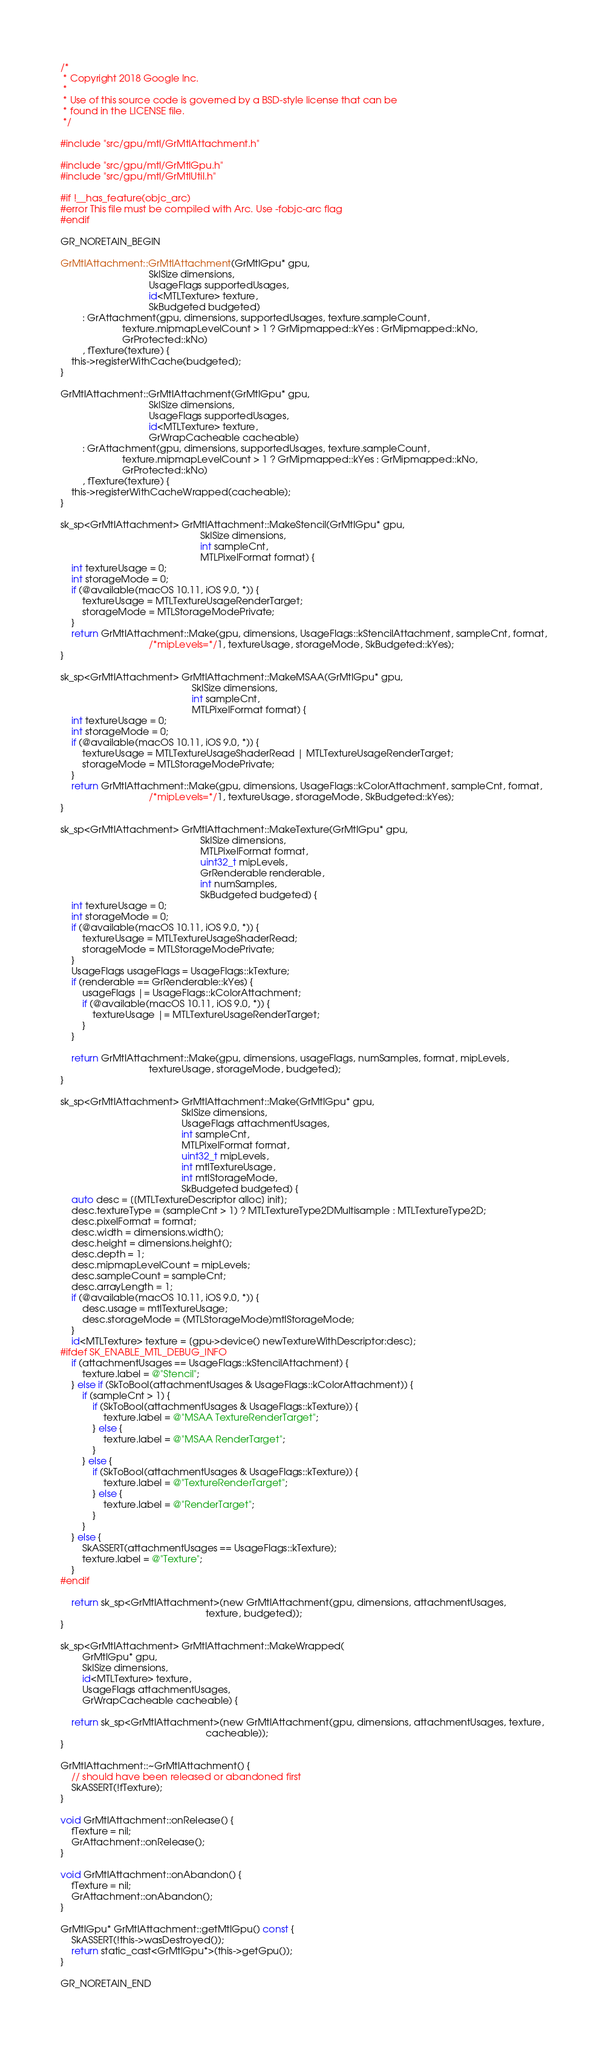<code> <loc_0><loc_0><loc_500><loc_500><_ObjectiveC_>/*
 * Copyright 2018 Google Inc.
 *
 * Use of this source code is governed by a BSD-style license that can be
 * found in the LICENSE file.
 */

#include "src/gpu/mtl/GrMtlAttachment.h"

#include "src/gpu/mtl/GrMtlGpu.h"
#include "src/gpu/mtl/GrMtlUtil.h"

#if !__has_feature(objc_arc)
#error This file must be compiled with Arc. Use -fobjc-arc flag
#endif

GR_NORETAIN_BEGIN

GrMtlAttachment::GrMtlAttachment(GrMtlGpu* gpu,
                                 SkISize dimensions,
                                 UsageFlags supportedUsages,
                                 id<MTLTexture> texture,
                                 SkBudgeted budgeted)
        : GrAttachment(gpu, dimensions, supportedUsages, texture.sampleCount,
                       texture.mipmapLevelCount > 1 ? GrMipmapped::kYes : GrMipmapped::kNo,
                       GrProtected::kNo)
        , fTexture(texture) {
    this->registerWithCache(budgeted);
}

GrMtlAttachment::GrMtlAttachment(GrMtlGpu* gpu,
                                 SkISize dimensions,
                                 UsageFlags supportedUsages,
                                 id<MTLTexture> texture,
                                 GrWrapCacheable cacheable)
        : GrAttachment(gpu, dimensions, supportedUsages, texture.sampleCount,
                       texture.mipmapLevelCount > 1 ? GrMipmapped::kYes : GrMipmapped::kNo,
                       GrProtected::kNo)
        , fTexture(texture) {
    this->registerWithCacheWrapped(cacheable);
}

sk_sp<GrMtlAttachment> GrMtlAttachment::MakeStencil(GrMtlGpu* gpu,
                                                    SkISize dimensions,
                                                    int sampleCnt,
                                                    MTLPixelFormat format) {
    int textureUsage = 0;
    int storageMode = 0;
    if (@available(macOS 10.11, iOS 9.0, *)) {
        textureUsage = MTLTextureUsageRenderTarget;
        storageMode = MTLStorageModePrivate;
    }
    return GrMtlAttachment::Make(gpu, dimensions, UsageFlags::kStencilAttachment, sampleCnt, format,
                                 /*mipLevels=*/1, textureUsage, storageMode, SkBudgeted::kYes);
}

sk_sp<GrMtlAttachment> GrMtlAttachment::MakeMSAA(GrMtlGpu* gpu,
                                                 SkISize dimensions,
                                                 int sampleCnt,
                                                 MTLPixelFormat format) {
    int textureUsage = 0;
    int storageMode = 0;
    if (@available(macOS 10.11, iOS 9.0, *)) {
        textureUsage = MTLTextureUsageShaderRead | MTLTextureUsageRenderTarget;
        storageMode = MTLStorageModePrivate;
    }
    return GrMtlAttachment::Make(gpu, dimensions, UsageFlags::kColorAttachment, sampleCnt, format,
                                 /*mipLevels=*/1, textureUsage, storageMode, SkBudgeted::kYes);
}

sk_sp<GrMtlAttachment> GrMtlAttachment::MakeTexture(GrMtlGpu* gpu,
                                                    SkISize dimensions,
                                                    MTLPixelFormat format,
                                                    uint32_t mipLevels,
                                                    GrRenderable renderable,
                                                    int numSamples,
                                                    SkBudgeted budgeted) {
    int textureUsage = 0;
    int storageMode = 0;
    if (@available(macOS 10.11, iOS 9.0, *)) {
        textureUsage = MTLTextureUsageShaderRead;
        storageMode = MTLStorageModePrivate;
    }
    UsageFlags usageFlags = UsageFlags::kTexture;
    if (renderable == GrRenderable::kYes) {
        usageFlags |= UsageFlags::kColorAttachment;
        if (@available(macOS 10.11, iOS 9.0, *)) {
            textureUsage |= MTLTextureUsageRenderTarget;
        }
    }

    return GrMtlAttachment::Make(gpu, dimensions, usageFlags, numSamples, format, mipLevels,
                                 textureUsage, storageMode, budgeted);
}

sk_sp<GrMtlAttachment> GrMtlAttachment::Make(GrMtlGpu* gpu,
                                             SkISize dimensions,
                                             UsageFlags attachmentUsages,
                                             int sampleCnt,
                                             MTLPixelFormat format,
                                             uint32_t mipLevels,
                                             int mtlTextureUsage,
                                             int mtlStorageMode,
                                             SkBudgeted budgeted) {
    auto desc = [[MTLTextureDescriptor alloc] init];
    desc.textureType = (sampleCnt > 1) ? MTLTextureType2DMultisample : MTLTextureType2D;
    desc.pixelFormat = format;
    desc.width = dimensions.width();
    desc.height = dimensions.height();
    desc.depth = 1;
    desc.mipmapLevelCount = mipLevels;
    desc.sampleCount = sampleCnt;
    desc.arrayLength = 1;
    if (@available(macOS 10.11, iOS 9.0, *)) {
        desc.usage = mtlTextureUsage;
        desc.storageMode = (MTLStorageMode)mtlStorageMode;
    }
    id<MTLTexture> texture = [gpu->device() newTextureWithDescriptor:desc];
#ifdef SK_ENABLE_MTL_DEBUG_INFO
    if (attachmentUsages == UsageFlags::kStencilAttachment) {
        texture.label = @"Stencil";
    } else if (SkToBool(attachmentUsages & UsageFlags::kColorAttachment)) {
        if (sampleCnt > 1) {
            if (SkToBool(attachmentUsages & UsageFlags::kTexture)) {
                texture.label = @"MSAA TextureRenderTarget";
            } else {
                texture.label = @"MSAA RenderTarget";
            }
        } else {
            if (SkToBool(attachmentUsages & UsageFlags::kTexture)) {
                texture.label = @"TextureRenderTarget";
            } else {
                texture.label = @"RenderTarget";
            }
        }
    } else {
        SkASSERT(attachmentUsages == UsageFlags::kTexture);
        texture.label = @"Texture";
    }
#endif

    return sk_sp<GrMtlAttachment>(new GrMtlAttachment(gpu, dimensions, attachmentUsages,
                                                      texture, budgeted));
}

sk_sp<GrMtlAttachment> GrMtlAttachment::MakeWrapped(
        GrMtlGpu* gpu,
        SkISize dimensions,
        id<MTLTexture> texture,
        UsageFlags attachmentUsages,
        GrWrapCacheable cacheable) {

    return sk_sp<GrMtlAttachment>(new GrMtlAttachment(gpu, dimensions, attachmentUsages, texture,
                                                      cacheable));
}

GrMtlAttachment::~GrMtlAttachment() {
    // should have been released or abandoned first
    SkASSERT(!fTexture);
}

void GrMtlAttachment::onRelease() {
    fTexture = nil;
    GrAttachment::onRelease();
}

void GrMtlAttachment::onAbandon() {
    fTexture = nil;
    GrAttachment::onAbandon();
}

GrMtlGpu* GrMtlAttachment::getMtlGpu() const {
    SkASSERT(!this->wasDestroyed());
    return static_cast<GrMtlGpu*>(this->getGpu());
}

GR_NORETAIN_END
</code> 